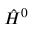<formula> <loc_0><loc_0><loc_500><loc_500>{ \hat { H } } ^ { 0 }</formula> 